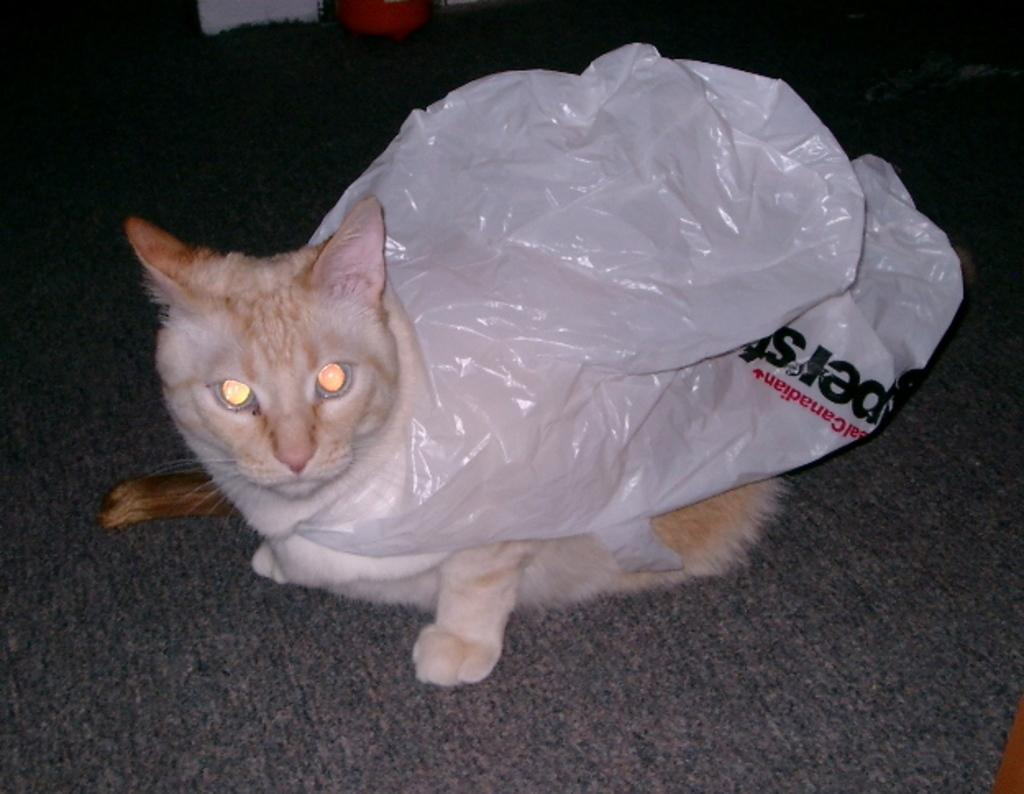What animal is present in the image? There is a cat in the image. Where is the cat located? The cat is on a carpet. Is there anything covering the cat? Yes, there is a plastic cover on the cat. What type of news can be heard coming from the goose in the image? There is no goose present in the image, so it is not possible to determine what, if any, news might be heard. 